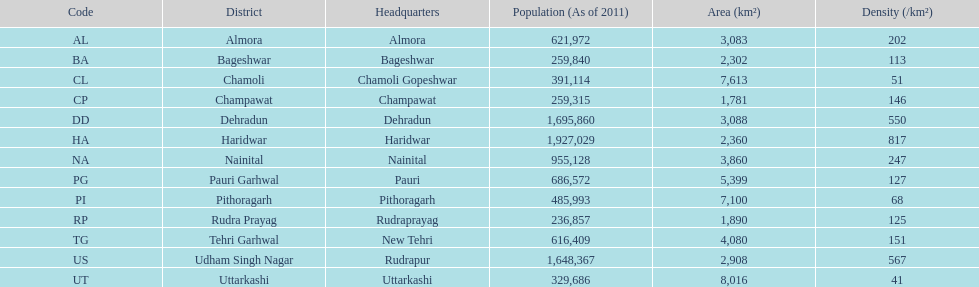Which code is above cl BA. Help me parse the entirety of this table. {'header': ['Code', 'District', 'Headquarters', 'Population (As of 2011)', 'Area (km²)', 'Density (/km²)'], 'rows': [['AL', 'Almora', 'Almora', '621,972', '3,083', '202'], ['BA', 'Bageshwar', 'Bageshwar', '259,840', '2,302', '113'], ['CL', 'Chamoli', 'Chamoli Gopeshwar', '391,114', '7,613', '51'], ['CP', 'Champawat', 'Champawat', '259,315', '1,781', '146'], ['DD', 'Dehradun', 'Dehradun', '1,695,860', '3,088', '550'], ['HA', 'Haridwar', 'Haridwar', '1,927,029', '2,360', '817'], ['NA', 'Nainital', 'Nainital', '955,128', '3,860', '247'], ['PG', 'Pauri Garhwal', 'Pauri', '686,572', '5,399', '127'], ['PI', 'Pithoragarh', 'Pithoragarh', '485,993', '7,100', '68'], ['RP', 'Rudra Prayag', 'Rudraprayag', '236,857', '1,890', '125'], ['TG', 'Tehri Garhwal', 'New Tehri', '616,409', '4,080', '151'], ['US', 'Udham Singh Nagar', 'Rudrapur', '1,648,367', '2,908', '567'], ['UT', 'Uttarkashi', 'Uttarkashi', '329,686', '8,016', '41']]} 